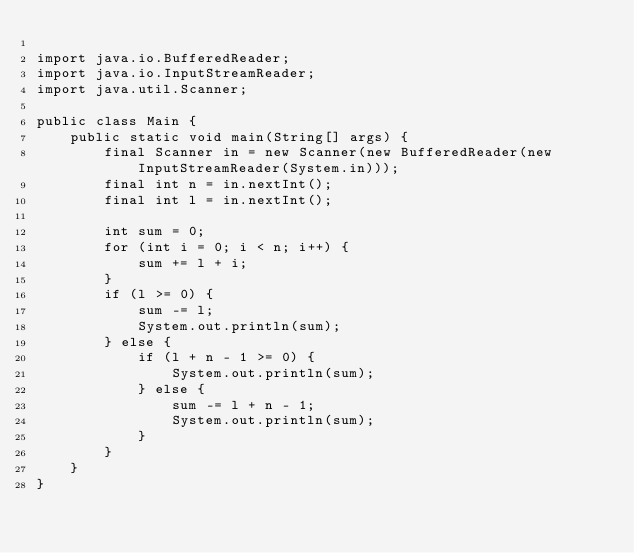Convert code to text. <code><loc_0><loc_0><loc_500><loc_500><_Java_>
import java.io.BufferedReader;
import java.io.InputStreamReader;
import java.util.Scanner;

public class Main {
    public static void main(String[] args) {
        final Scanner in = new Scanner(new BufferedReader(new InputStreamReader(System.in)));
        final int n = in.nextInt();
        final int l = in.nextInt();

        int sum = 0;
        for (int i = 0; i < n; i++) {
            sum += l + i;
        }
        if (l >= 0) {
            sum -= l;
            System.out.println(sum);
        } else {
            if (l + n - 1 >= 0) {
                System.out.println(sum);
            } else {
                sum -= l + n - 1;
                System.out.println(sum);
            }
        }
    }
}
</code> 